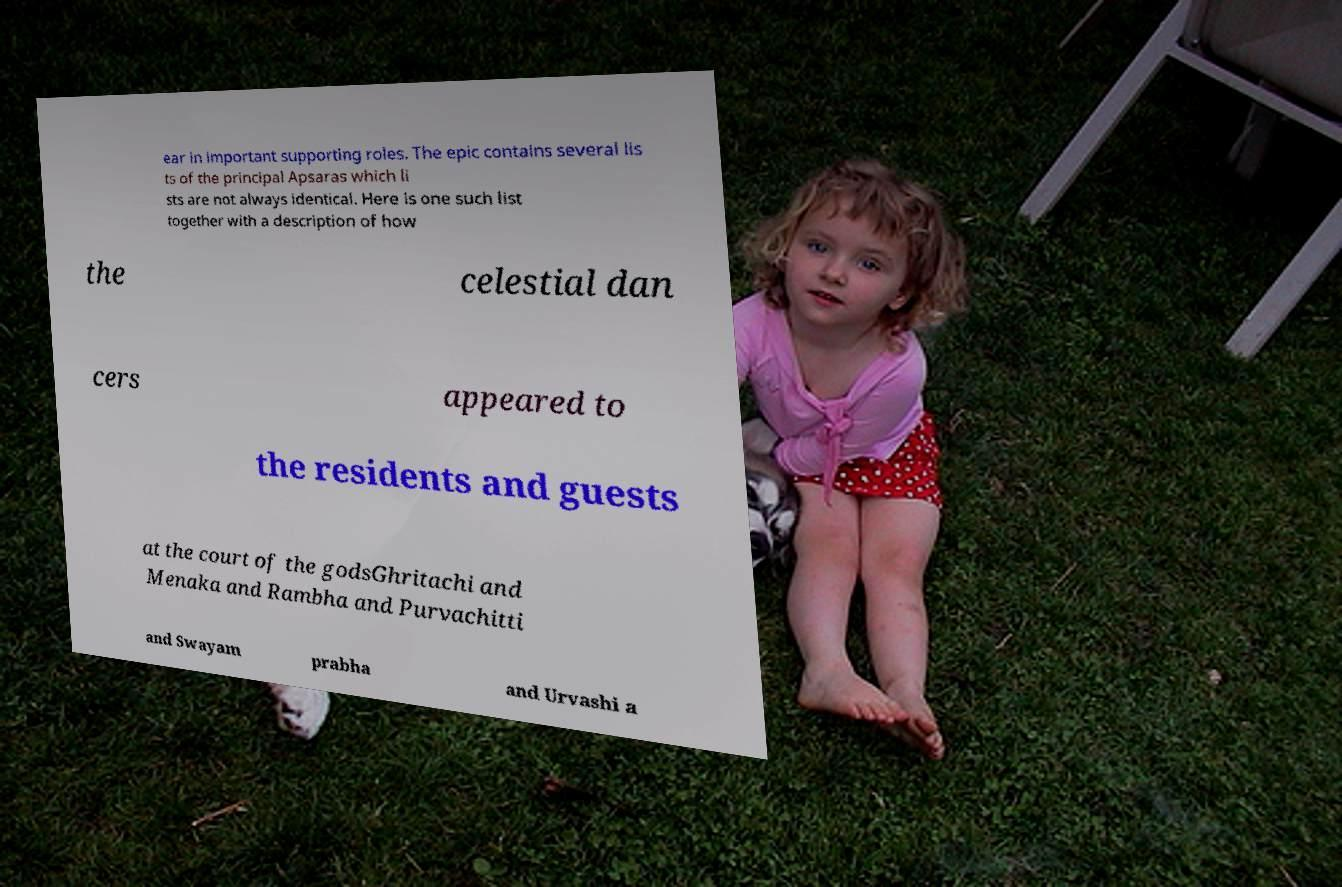I need the written content from this picture converted into text. Can you do that? ear in important supporting roles. The epic contains several lis ts of the principal Apsaras which li sts are not always identical. Here is one such list together with a description of how the celestial dan cers appeared to the residents and guests at the court of the godsGhritachi and Menaka and Rambha and Purvachitti and Swayam prabha and Urvashi a 